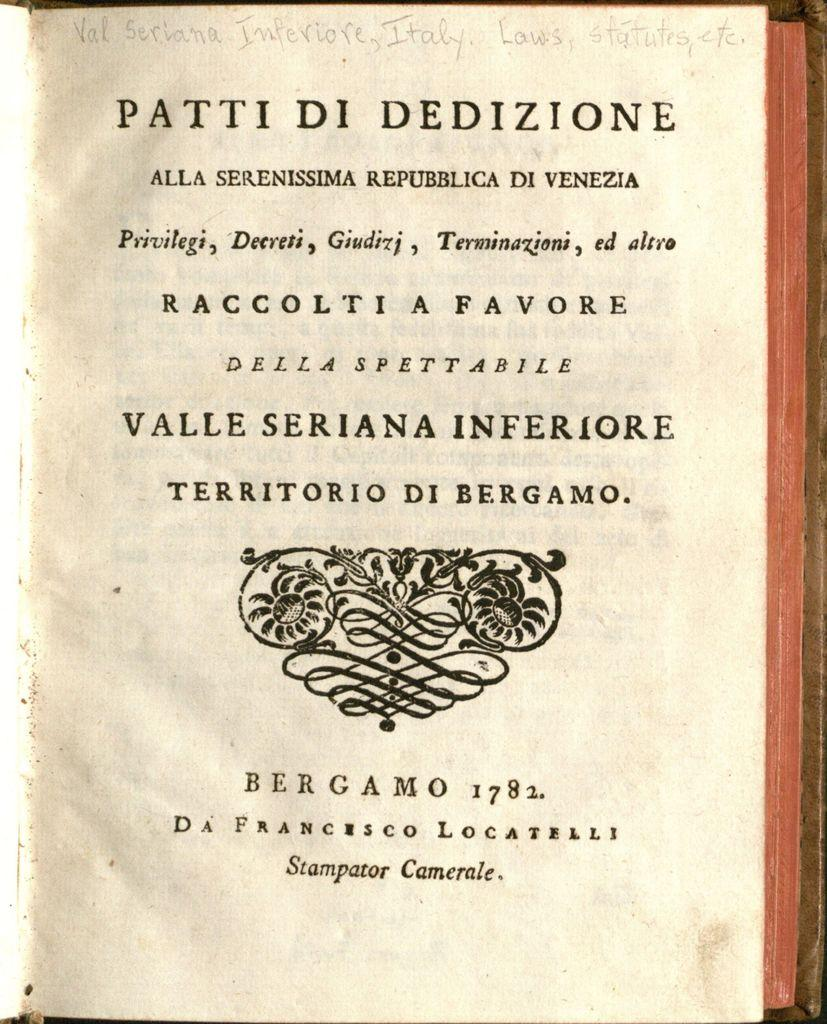<image>
Offer a succinct explanation of the picture presented. the first page of the book Patti Di Dedizione 